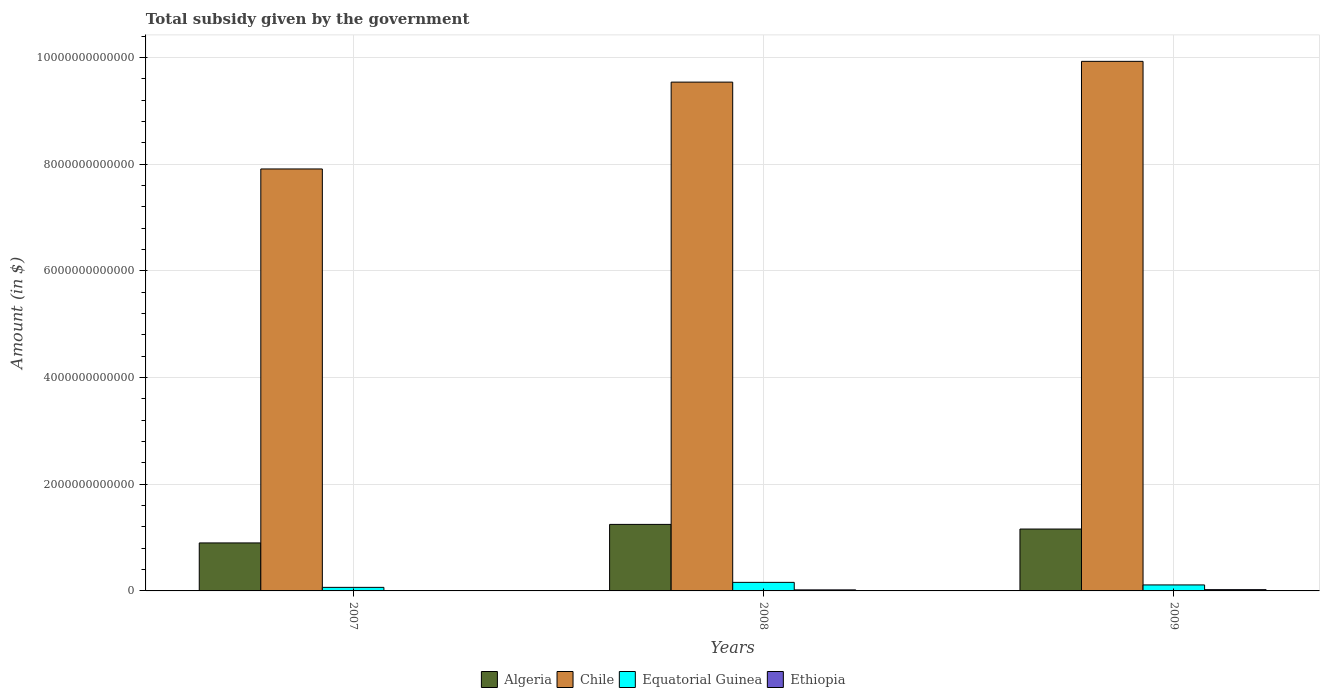How many groups of bars are there?
Your response must be concise. 3. Are the number of bars per tick equal to the number of legend labels?
Your answer should be compact. Yes. Are the number of bars on each tick of the X-axis equal?
Your response must be concise. Yes. How many bars are there on the 2nd tick from the left?
Give a very brief answer. 4. What is the label of the 3rd group of bars from the left?
Provide a short and direct response. 2009. What is the total revenue collected by the government in Chile in 2008?
Give a very brief answer. 9.54e+12. Across all years, what is the maximum total revenue collected by the government in Ethiopia?
Your answer should be compact. 2.37e+1. Across all years, what is the minimum total revenue collected by the government in Equatorial Guinea?
Provide a succinct answer. 6.67e+1. In which year was the total revenue collected by the government in Ethiopia maximum?
Offer a terse response. 2009. What is the total total revenue collected by the government in Equatorial Guinea in the graph?
Provide a succinct answer. 3.40e+11. What is the difference between the total revenue collected by the government in Ethiopia in 2008 and that in 2009?
Offer a terse response. -4.33e+09. What is the difference between the total revenue collected by the government in Algeria in 2007 and the total revenue collected by the government in Ethiopia in 2009?
Provide a short and direct response. 8.76e+11. What is the average total revenue collected by the government in Ethiopia per year?
Ensure brevity in your answer.  1.48e+1. In the year 2009, what is the difference between the total revenue collected by the government in Algeria and total revenue collected by the government in Chile?
Offer a very short reply. -8.77e+12. What is the ratio of the total revenue collected by the government in Algeria in 2008 to that in 2009?
Keep it short and to the point. 1.08. Is the difference between the total revenue collected by the government in Algeria in 2007 and 2009 greater than the difference between the total revenue collected by the government in Chile in 2007 and 2009?
Provide a short and direct response. Yes. What is the difference between the highest and the second highest total revenue collected by the government in Chile?
Offer a terse response. 3.89e+11. What is the difference between the highest and the lowest total revenue collected by the government in Chile?
Ensure brevity in your answer.  2.02e+12. Is the sum of the total revenue collected by the government in Chile in 2008 and 2009 greater than the maximum total revenue collected by the government in Ethiopia across all years?
Make the answer very short. Yes. Is it the case that in every year, the sum of the total revenue collected by the government in Algeria and total revenue collected by the government in Ethiopia is greater than the sum of total revenue collected by the government in Equatorial Guinea and total revenue collected by the government in Chile?
Provide a succinct answer. No. What does the 2nd bar from the left in 2009 represents?
Your answer should be very brief. Chile. What does the 2nd bar from the right in 2007 represents?
Ensure brevity in your answer.  Equatorial Guinea. Is it the case that in every year, the sum of the total revenue collected by the government in Equatorial Guinea and total revenue collected by the government in Ethiopia is greater than the total revenue collected by the government in Chile?
Your answer should be compact. No. How many bars are there?
Ensure brevity in your answer.  12. What is the difference between two consecutive major ticks on the Y-axis?
Make the answer very short. 2.00e+12. Does the graph contain any zero values?
Ensure brevity in your answer.  No. Where does the legend appear in the graph?
Offer a very short reply. Bottom center. How are the legend labels stacked?
Your answer should be compact. Horizontal. What is the title of the graph?
Make the answer very short. Total subsidy given by the government. What is the label or title of the X-axis?
Provide a short and direct response. Years. What is the label or title of the Y-axis?
Keep it short and to the point. Amount (in $). What is the Amount (in $) of Algeria in 2007?
Give a very brief answer. 9.00e+11. What is the Amount (in $) of Chile in 2007?
Give a very brief answer. 7.91e+12. What is the Amount (in $) of Equatorial Guinea in 2007?
Your answer should be very brief. 6.67e+1. What is the Amount (in $) of Ethiopia in 2007?
Ensure brevity in your answer.  1.15e+09. What is the Amount (in $) of Algeria in 2008?
Provide a succinct answer. 1.25e+12. What is the Amount (in $) in Chile in 2008?
Provide a short and direct response. 9.54e+12. What is the Amount (in $) of Equatorial Guinea in 2008?
Ensure brevity in your answer.  1.60e+11. What is the Amount (in $) in Ethiopia in 2008?
Your answer should be very brief. 1.94e+1. What is the Amount (in $) in Algeria in 2009?
Provide a short and direct response. 1.16e+12. What is the Amount (in $) in Chile in 2009?
Offer a very short reply. 9.93e+12. What is the Amount (in $) in Equatorial Guinea in 2009?
Offer a very short reply. 1.12e+11. What is the Amount (in $) of Ethiopia in 2009?
Provide a short and direct response. 2.37e+1. Across all years, what is the maximum Amount (in $) in Algeria?
Give a very brief answer. 1.25e+12. Across all years, what is the maximum Amount (in $) of Chile?
Keep it short and to the point. 9.93e+12. Across all years, what is the maximum Amount (in $) in Equatorial Guinea?
Ensure brevity in your answer.  1.60e+11. Across all years, what is the maximum Amount (in $) of Ethiopia?
Your answer should be compact. 2.37e+1. Across all years, what is the minimum Amount (in $) in Algeria?
Your answer should be compact. 9.00e+11. Across all years, what is the minimum Amount (in $) of Chile?
Offer a very short reply. 7.91e+12. Across all years, what is the minimum Amount (in $) in Equatorial Guinea?
Provide a succinct answer. 6.67e+1. Across all years, what is the minimum Amount (in $) in Ethiopia?
Give a very brief answer. 1.15e+09. What is the total Amount (in $) in Algeria in the graph?
Your response must be concise. 3.31e+12. What is the total Amount (in $) of Chile in the graph?
Offer a very short reply. 2.74e+13. What is the total Amount (in $) of Equatorial Guinea in the graph?
Provide a short and direct response. 3.40e+11. What is the total Amount (in $) of Ethiopia in the graph?
Your answer should be very brief. 4.43e+1. What is the difference between the Amount (in $) of Algeria in 2007 and that in 2008?
Keep it short and to the point. -3.47e+11. What is the difference between the Amount (in $) in Chile in 2007 and that in 2008?
Your answer should be compact. -1.63e+12. What is the difference between the Amount (in $) in Equatorial Guinea in 2007 and that in 2008?
Your answer should be very brief. -9.38e+1. What is the difference between the Amount (in $) in Ethiopia in 2007 and that in 2008?
Provide a short and direct response. -1.82e+1. What is the difference between the Amount (in $) in Algeria in 2007 and that in 2009?
Your answer should be compact. -2.60e+11. What is the difference between the Amount (in $) in Chile in 2007 and that in 2009?
Your answer should be very brief. -2.02e+12. What is the difference between the Amount (in $) of Equatorial Guinea in 2007 and that in 2009?
Give a very brief answer. -4.58e+1. What is the difference between the Amount (in $) of Ethiopia in 2007 and that in 2009?
Offer a very short reply. -2.26e+1. What is the difference between the Amount (in $) of Algeria in 2008 and that in 2009?
Make the answer very short. 8.71e+1. What is the difference between the Amount (in $) of Chile in 2008 and that in 2009?
Offer a terse response. -3.89e+11. What is the difference between the Amount (in $) in Equatorial Guinea in 2008 and that in 2009?
Your response must be concise. 4.80e+1. What is the difference between the Amount (in $) of Ethiopia in 2008 and that in 2009?
Ensure brevity in your answer.  -4.33e+09. What is the difference between the Amount (in $) in Algeria in 2007 and the Amount (in $) in Chile in 2008?
Ensure brevity in your answer.  -8.64e+12. What is the difference between the Amount (in $) of Algeria in 2007 and the Amount (in $) of Equatorial Guinea in 2008?
Your answer should be very brief. 7.39e+11. What is the difference between the Amount (in $) in Algeria in 2007 and the Amount (in $) in Ethiopia in 2008?
Your answer should be very brief. 8.80e+11. What is the difference between the Amount (in $) of Chile in 2007 and the Amount (in $) of Equatorial Guinea in 2008?
Offer a very short reply. 7.75e+12. What is the difference between the Amount (in $) of Chile in 2007 and the Amount (in $) of Ethiopia in 2008?
Make the answer very short. 7.89e+12. What is the difference between the Amount (in $) of Equatorial Guinea in 2007 and the Amount (in $) of Ethiopia in 2008?
Make the answer very short. 4.73e+1. What is the difference between the Amount (in $) in Algeria in 2007 and the Amount (in $) in Chile in 2009?
Offer a terse response. -9.03e+12. What is the difference between the Amount (in $) of Algeria in 2007 and the Amount (in $) of Equatorial Guinea in 2009?
Ensure brevity in your answer.  7.87e+11. What is the difference between the Amount (in $) in Algeria in 2007 and the Amount (in $) in Ethiopia in 2009?
Ensure brevity in your answer.  8.76e+11. What is the difference between the Amount (in $) in Chile in 2007 and the Amount (in $) in Equatorial Guinea in 2009?
Offer a terse response. 7.80e+12. What is the difference between the Amount (in $) of Chile in 2007 and the Amount (in $) of Ethiopia in 2009?
Give a very brief answer. 7.89e+12. What is the difference between the Amount (in $) in Equatorial Guinea in 2007 and the Amount (in $) in Ethiopia in 2009?
Offer a very short reply. 4.30e+1. What is the difference between the Amount (in $) of Algeria in 2008 and the Amount (in $) of Chile in 2009?
Your answer should be compact. -8.68e+12. What is the difference between the Amount (in $) of Algeria in 2008 and the Amount (in $) of Equatorial Guinea in 2009?
Your answer should be very brief. 1.13e+12. What is the difference between the Amount (in $) of Algeria in 2008 and the Amount (in $) of Ethiopia in 2009?
Your answer should be compact. 1.22e+12. What is the difference between the Amount (in $) in Chile in 2008 and the Amount (in $) in Equatorial Guinea in 2009?
Your response must be concise. 9.43e+12. What is the difference between the Amount (in $) in Chile in 2008 and the Amount (in $) in Ethiopia in 2009?
Your response must be concise. 9.52e+12. What is the difference between the Amount (in $) of Equatorial Guinea in 2008 and the Amount (in $) of Ethiopia in 2009?
Ensure brevity in your answer.  1.37e+11. What is the average Amount (in $) in Algeria per year?
Give a very brief answer. 1.10e+12. What is the average Amount (in $) in Chile per year?
Make the answer very short. 9.13e+12. What is the average Amount (in $) in Equatorial Guinea per year?
Keep it short and to the point. 1.13e+11. What is the average Amount (in $) of Ethiopia per year?
Provide a succinct answer. 1.48e+1. In the year 2007, what is the difference between the Amount (in $) in Algeria and Amount (in $) in Chile?
Make the answer very short. -7.01e+12. In the year 2007, what is the difference between the Amount (in $) in Algeria and Amount (in $) in Equatorial Guinea?
Offer a terse response. 8.33e+11. In the year 2007, what is the difference between the Amount (in $) of Algeria and Amount (in $) of Ethiopia?
Make the answer very short. 8.99e+11. In the year 2007, what is the difference between the Amount (in $) in Chile and Amount (in $) in Equatorial Guinea?
Offer a terse response. 7.84e+12. In the year 2007, what is the difference between the Amount (in $) in Chile and Amount (in $) in Ethiopia?
Your answer should be very brief. 7.91e+12. In the year 2007, what is the difference between the Amount (in $) of Equatorial Guinea and Amount (in $) of Ethiopia?
Provide a short and direct response. 6.55e+1. In the year 2008, what is the difference between the Amount (in $) of Algeria and Amount (in $) of Chile?
Make the answer very short. -8.29e+12. In the year 2008, what is the difference between the Amount (in $) in Algeria and Amount (in $) in Equatorial Guinea?
Provide a short and direct response. 1.09e+12. In the year 2008, what is the difference between the Amount (in $) of Algeria and Amount (in $) of Ethiopia?
Keep it short and to the point. 1.23e+12. In the year 2008, what is the difference between the Amount (in $) of Chile and Amount (in $) of Equatorial Guinea?
Your answer should be compact. 9.38e+12. In the year 2008, what is the difference between the Amount (in $) in Chile and Amount (in $) in Ethiopia?
Offer a very short reply. 9.52e+12. In the year 2008, what is the difference between the Amount (in $) in Equatorial Guinea and Amount (in $) in Ethiopia?
Your answer should be compact. 1.41e+11. In the year 2009, what is the difference between the Amount (in $) of Algeria and Amount (in $) of Chile?
Offer a very short reply. -8.77e+12. In the year 2009, what is the difference between the Amount (in $) of Algeria and Amount (in $) of Equatorial Guinea?
Provide a succinct answer. 1.05e+12. In the year 2009, what is the difference between the Amount (in $) in Algeria and Amount (in $) in Ethiopia?
Offer a terse response. 1.14e+12. In the year 2009, what is the difference between the Amount (in $) of Chile and Amount (in $) of Equatorial Guinea?
Ensure brevity in your answer.  9.82e+12. In the year 2009, what is the difference between the Amount (in $) in Chile and Amount (in $) in Ethiopia?
Give a very brief answer. 9.90e+12. In the year 2009, what is the difference between the Amount (in $) of Equatorial Guinea and Amount (in $) of Ethiopia?
Give a very brief answer. 8.87e+1. What is the ratio of the Amount (in $) of Algeria in 2007 to that in 2008?
Your answer should be compact. 0.72. What is the ratio of the Amount (in $) in Chile in 2007 to that in 2008?
Keep it short and to the point. 0.83. What is the ratio of the Amount (in $) in Equatorial Guinea in 2007 to that in 2008?
Your answer should be very brief. 0.42. What is the ratio of the Amount (in $) of Ethiopia in 2007 to that in 2008?
Provide a succinct answer. 0.06. What is the ratio of the Amount (in $) in Algeria in 2007 to that in 2009?
Keep it short and to the point. 0.78. What is the ratio of the Amount (in $) of Chile in 2007 to that in 2009?
Provide a short and direct response. 0.8. What is the ratio of the Amount (in $) in Equatorial Guinea in 2007 to that in 2009?
Keep it short and to the point. 0.59. What is the ratio of the Amount (in $) of Ethiopia in 2007 to that in 2009?
Your answer should be compact. 0.05. What is the ratio of the Amount (in $) in Algeria in 2008 to that in 2009?
Keep it short and to the point. 1.08. What is the ratio of the Amount (in $) of Chile in 2008 to that in 2009?
Keep it short and to the point. 0.96. What is the ratio of the Amount (in $) of Equatorial Guinea in 2008 to that in 2009?
Offer a terse response. 1.43. What is the ratio of the Amount (in $) in Ethiopia in 2008 to that in 2009?
Provide a succinct answer. 0.82. What is the difference between the highest and the second highest Amount (in $) of Algeria?
Give a very brief answer. 8.71e+1. What is the difference between the highest and the second highest Amount (in $) of Chile?
Your response must be concise. 3.89e+11. What is the difference between the highest and the second highest Amount (in $) of Equatorial Guinea?
Give a very brief answer. 4.80e+1. What is the difference between the highest and the second highest Amount (in $) in Ethiopia?
Your answer should be compact. 4.33e+09. What is the difference between the highest and the lowest Amount (in $) in Algeria?
Provide a short and direct response. 3.47e+11. What is the difference between the highest and the lowest Amount (in $) in Chile?
Make the answer very short. 2.02e+12. What is the difference between the highest and the lowest Amount (in $) in Equatorial Guinea?
Give a very brief answer. 9.38e+1. What is the difference between the highest and the lowest Amount (in $) of Ethiopia?
Your response must be concise. 2.26e+1. 